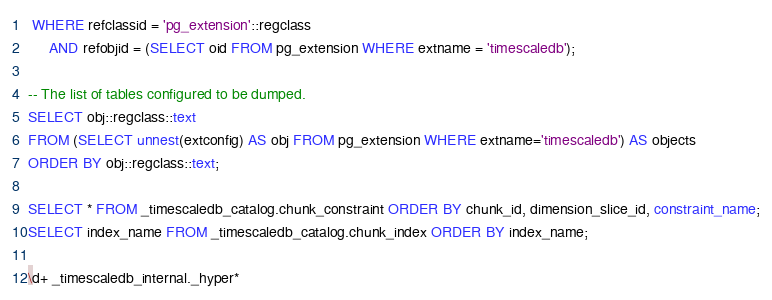Convert code to text. <code><loc_0><loc_0><loc_500><loc_500><_SQL_> WHERE refclassid = 'pg_extension'::regclass
     AND refobjid = (SELECT oid FROM pg_extension WHERE extname = 'timescaledb');

-- The list of tables configured to be dumped.
SELECT obj::regclass::text
FROM (SELECT unnest(extconfig) AS obj FROM pg_extension WHERE extname='timescaledb') AS objects
ORDER BY obj::regclass::text;

SELECT * FROM _timescaledb_catalog.chunk_constraint ORDER BY chunk_id, dimension_slice_id, constraint_name;
SELECT index_name FROM _timescaledb_catalog.chunk_index ORDER BY index_name;

\d+ _timescaledb_internal._hyper*
</code> 